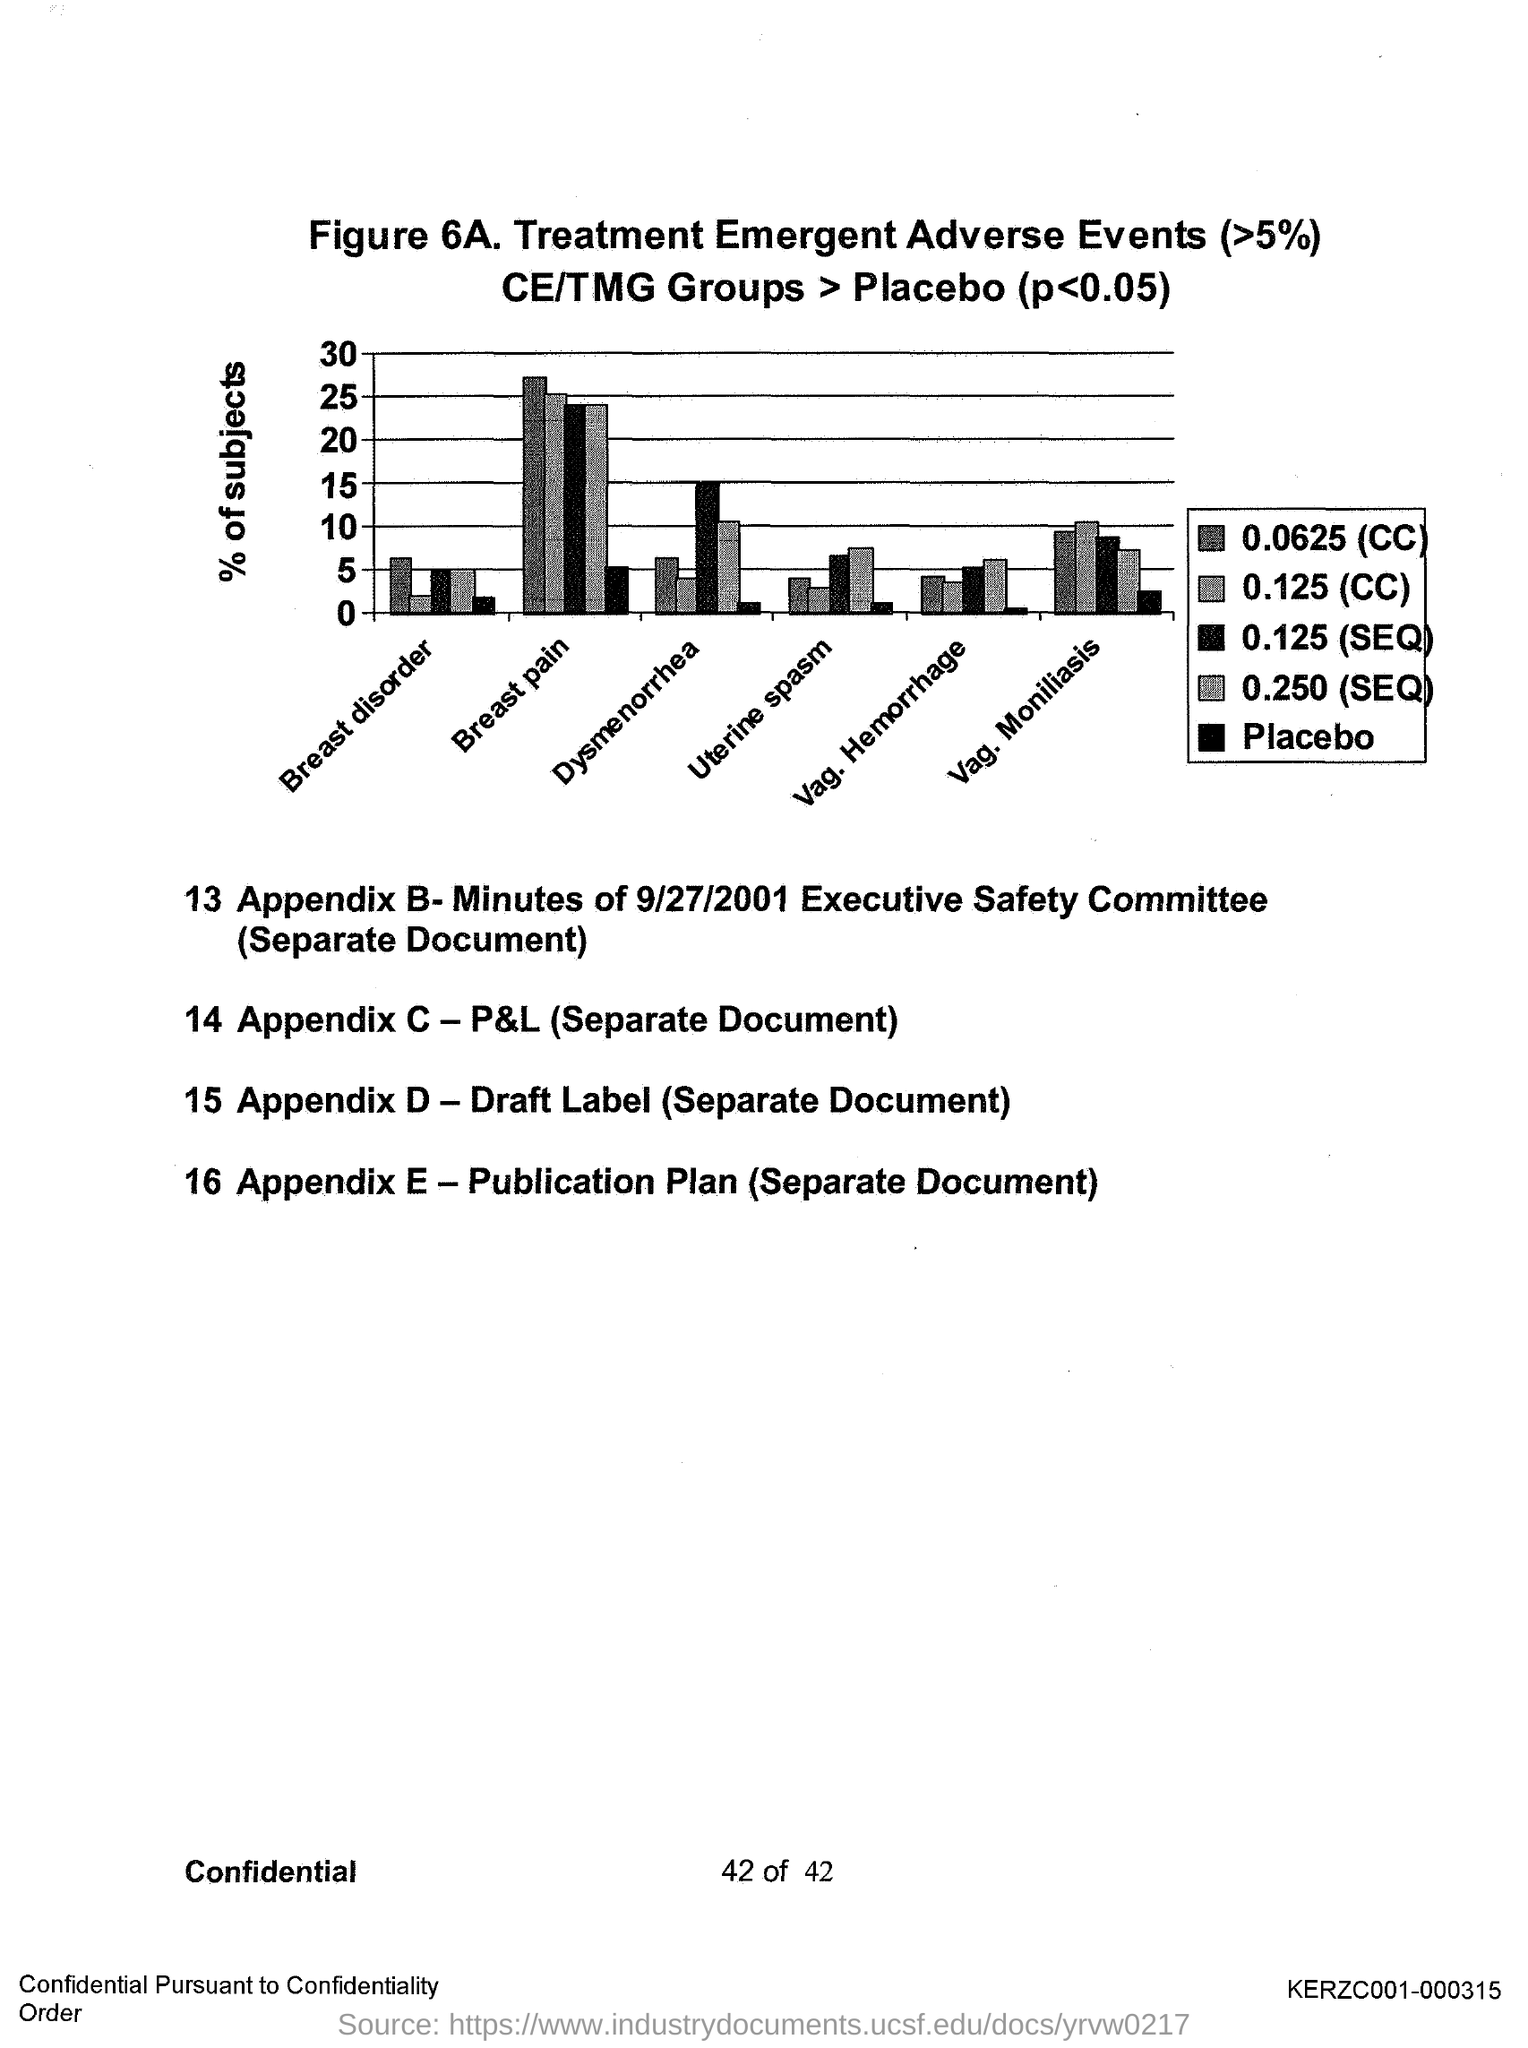Mention a couple of crucial points in this snapshot. The figure number is 6A. The y-axis represents the percentage of subjects who obtained a score of 3 or higher on the Likert scale for the "agree" or "strongly agree" response option for the item "I would recommend this course to others. 